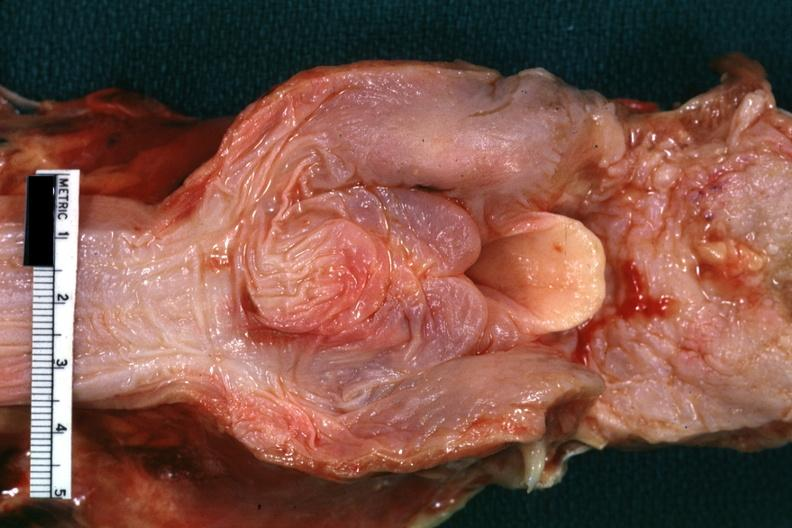does this image show view of hypopharyngeal tissue and unopened larynx nice example of severe edema?
Answer the question using a single word or phrase. Yes 